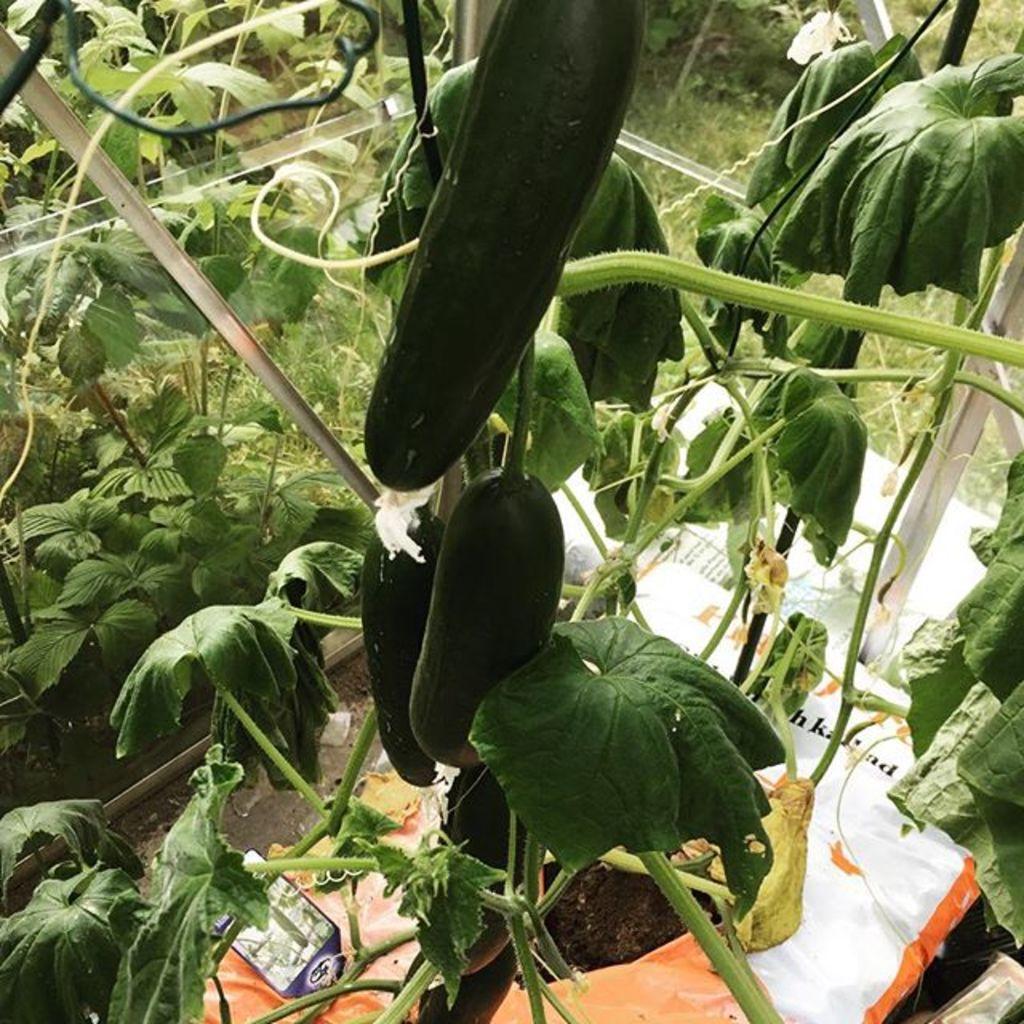Please provide a concise description of this image. In this image there are some vegetables and plants, and at the bottom there are some plastic covers and some objects. And in the background there is grass and some objects, and in the center is a glass door. 